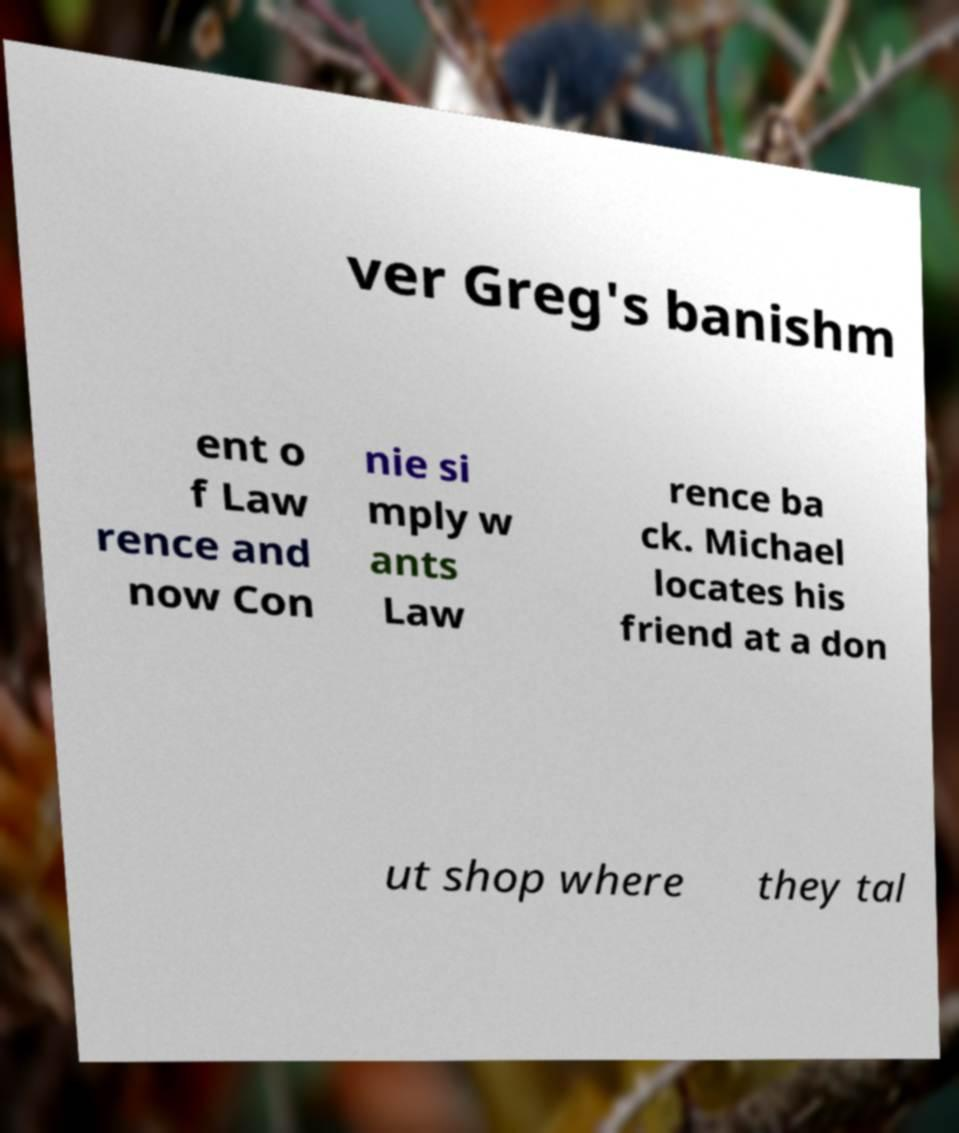For documentation purposes, I need the text within this image transcribed. Could you provide that? ver Greg's banishm ent o f Law rence and now Con nie si mply w ants Law rence ba ck. Michael locates his friend at a don ut shop where they tal 